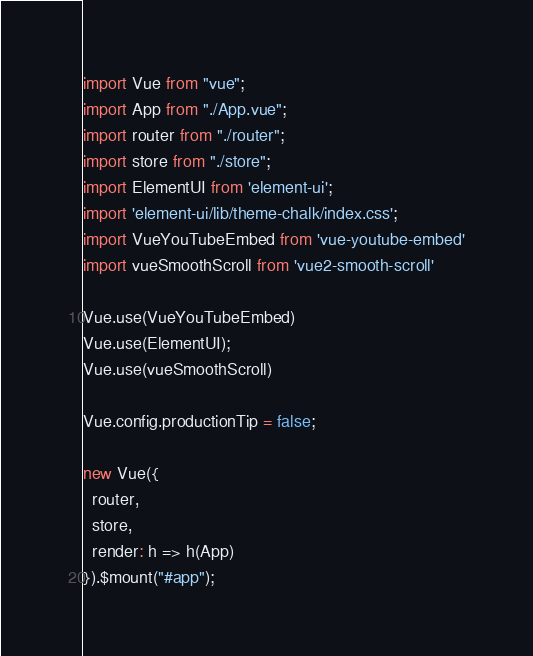<code> <loc_0><loc_0><loc_500><loc_500><_JavaScript_>import Vue from "vue";
import App from "./App.vue";
import router from "./router";
import store from "./store";
import ElementUI from 'element-ui';
import 'element-ui/lib/theme-chalk/index.css';
import VueYouTubeEmbed from 'vue-youtube-embed'
import vueSmoothScroll from 'vue2-smooth-scroll'

Vue.use(VueYouTubeEmbed)
Vue.use(ElementUI);
Vue.use(vueSmoothScroll)

Vue.config.productionTip = false;

new Vue({
  router,
  store,
  render: h => h(App)
}).$mount("#app");
</code> 